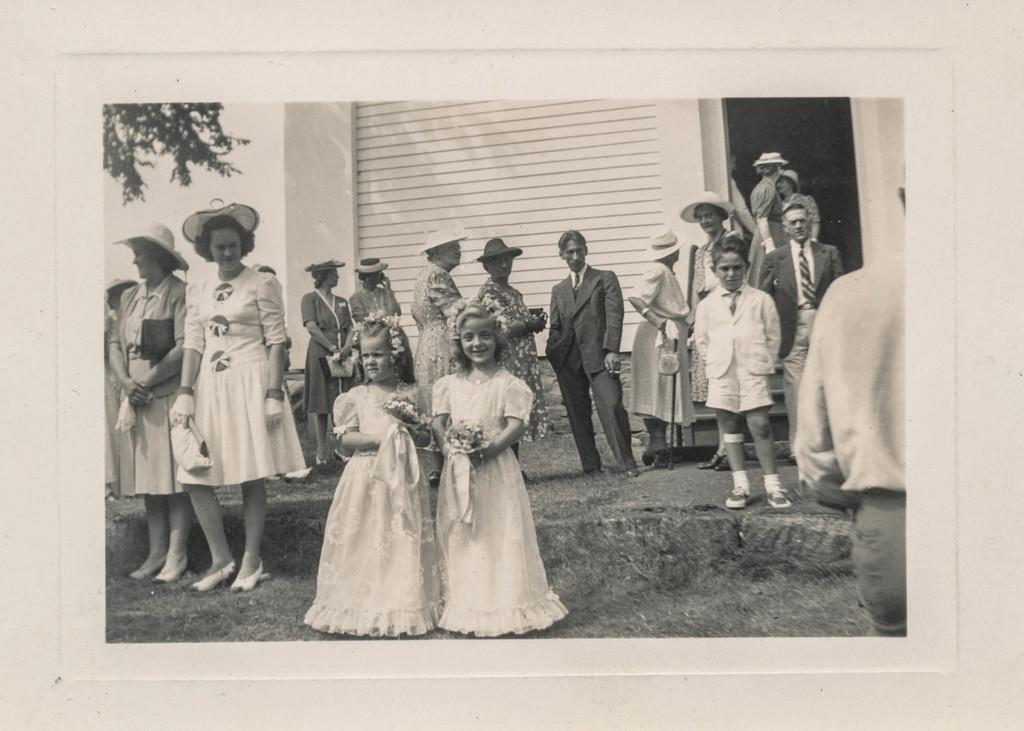Please provide a concise description of this image. In this picture there are two small girls standing in the front wearing white gown,smiling and giving a pose into the camera. Behind there are some persons standing and looking to them. On the left side there are two women standing and looking to them. Behind there is a white shed house and door. 